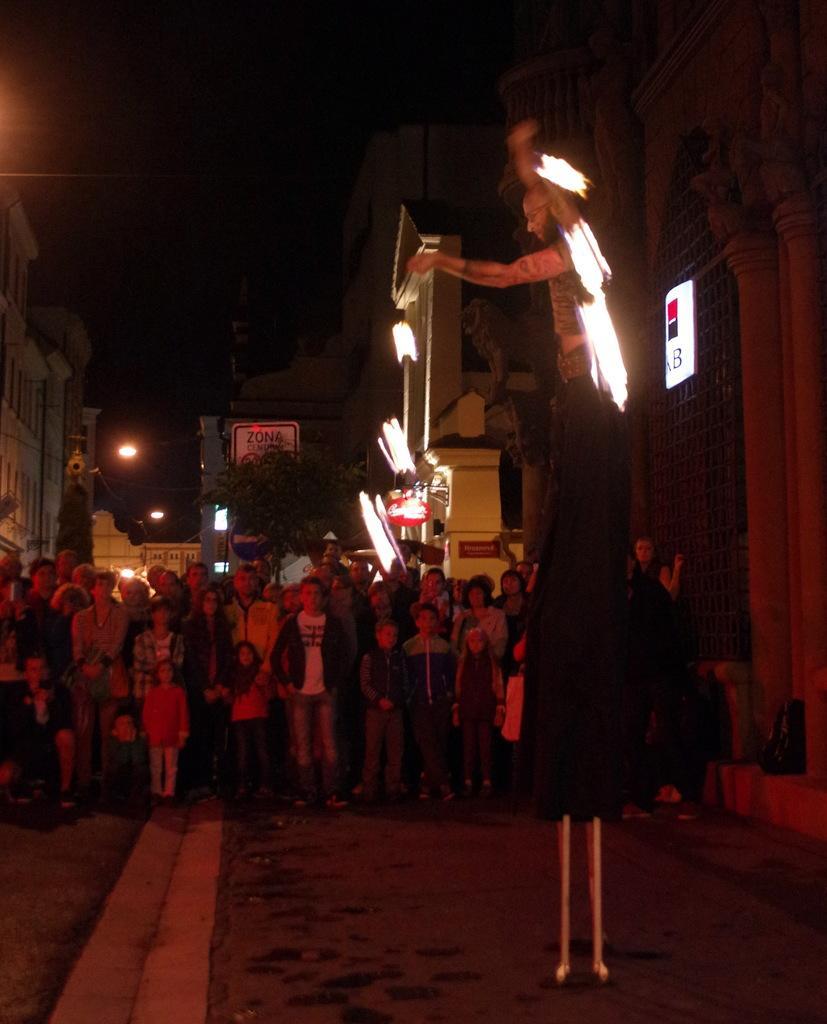Can you describe this image briefly? In this image in the foreground a person is performing stunts. He is standing on sticks. In the background there are many people watching the man. There are buildings, trees, lights in the back. 